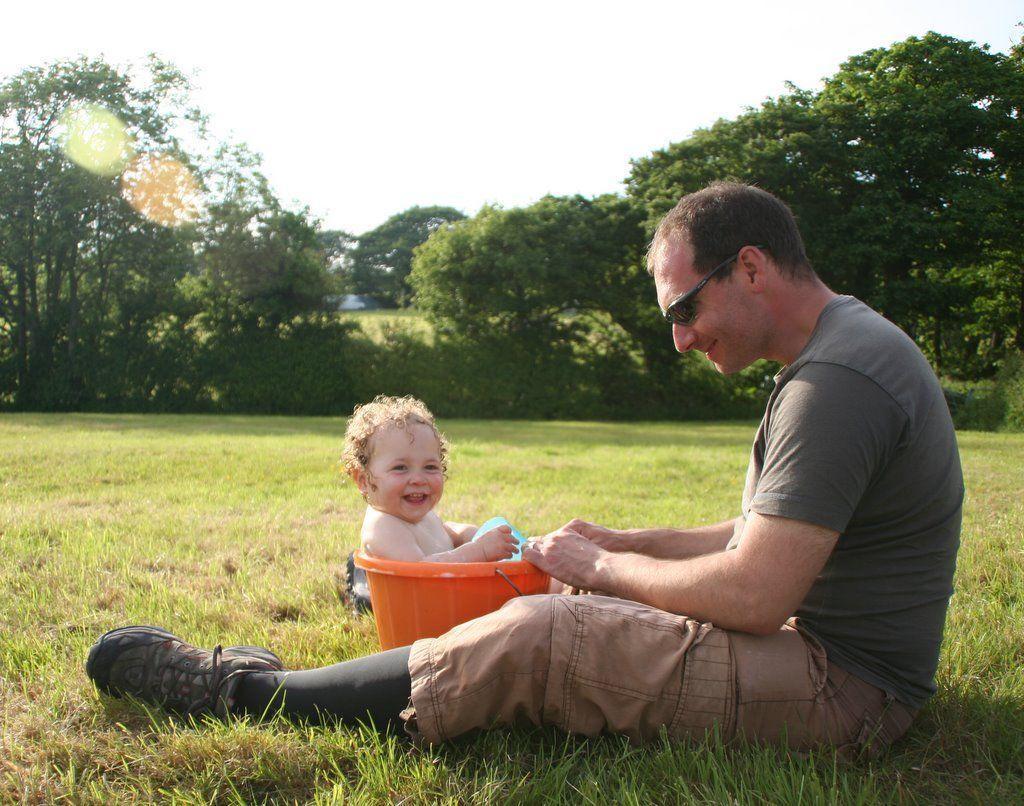Could you give a brief overview of what you see in this image? In this picture there is a man who is sitting on the grass floor at the right side of the image, he is playing with the baby and the baby is sitting in the bucket, there are trees all around the area of the image and it is a day time. 